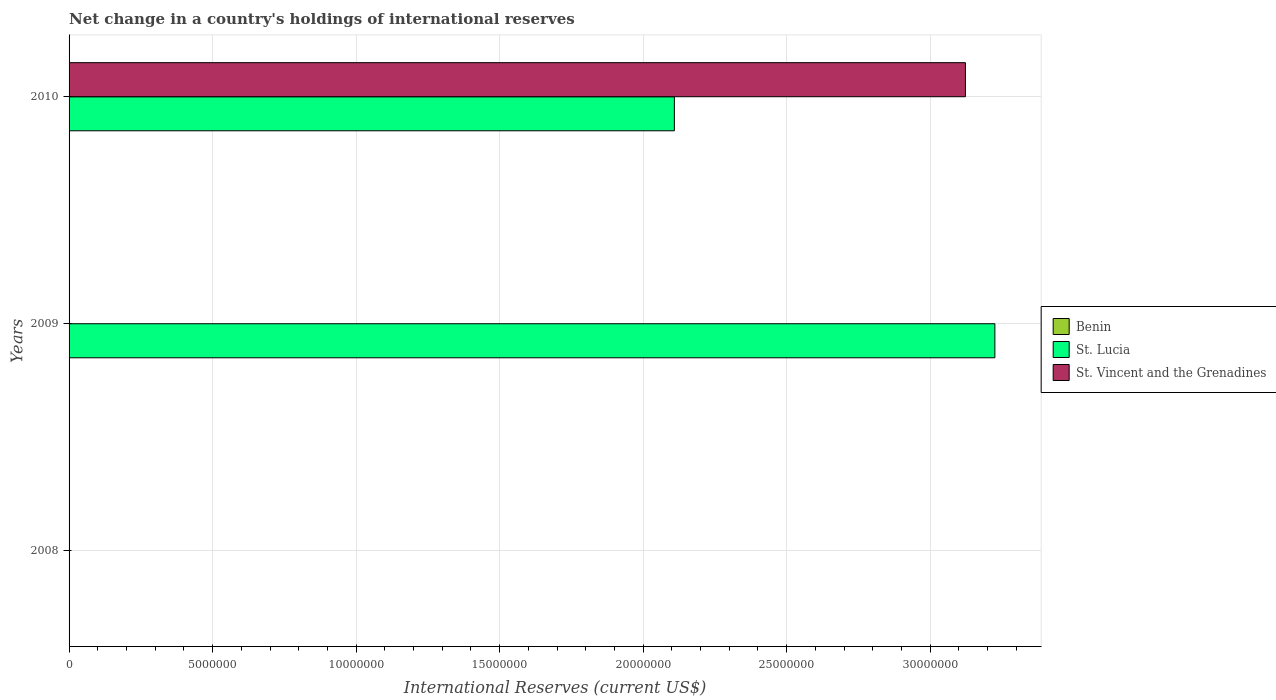Are the number of bars per tick equal to the number of legend labels?
Give a very brief answer. No. Are the number of bars on each tick of the Y-axis equal?
Your answer should be very brief. No. How many bars are there on the 2nd tick from the top?
Give a very brief answer. 1. How many bars are there on the 1st tick from the bottom?
Make the answer very short. 0. What is the label of the 2nd group of bars from the top?
Keep it short and to the point. 2009. In how many cases, is the number of bars for a given year not equal to the number of legend labels?
Your answer should be very brief. 3. Across all years, what is the maximum international reserves in St. Lucia?
Make the answer very short. 3.23e+07. In which year was the international reserves in St. Lucia maximum?
Offer a terse response. 2009. What is the total international reserves in St. Lucia in the graph?
Your answer should be compact. 5.33e+07. What is the difference between the international reserves in St. Vincent and the Grenadines in 2010 and the international reserves in St. Lucia in 2008?
Offer a very short reply. 3.12e+07. In how many years, is the international reserves in St. Vincent and the Grenadines greater than 29000000 US$?
Your response must be concise. 1. Is the international reserves in St. Lucia in 2009 less than that in 2010?
Provide a succinct answer. No. What is the difference between the highest and the lowest international reserves in St. Lucia?
Your response must be concise. 3.23e+07. Is it the case that in every year, the sum of the international reserves in St. Lucia and international reserves in Benin is greater than the international reserves in St. Vincent and the Grenadines?
Offer a very short reply. No. Are all the bars in the graph horizontal?
Make the answer very short. Yes. How many years are there in the graph?
Your answer should be compact. 3. Are the values on the major ticks of X-axis written in scientific E-notation?
Make the answer very short. No. Does the graph contain any zero values?
Provide a short and direct response. Yes. Where does the legend appear in the graph?
Your answer should be very brief. Center right. How many legend labels are there?
Provide a short and direct response. 3. What is the title of the graph?
Your answer should be compact. Net change in a country's holdings of international reserves. Does "Benin" appear as one of the legend labels in the graph?
Keep it short and to the point. Yes. What is the label or title of the X-axis?
Provide a short and direct response. International Reserves (current US$). What is the International Reserves (current US$) in St. Lucia in 2008?
Your answer should be compact. 0. What is the International Reserves (current US$) of St. Vincent and the Grenadines in 2008?
Keep it short and to the point. 0. What is the International Reserves (current US$) of St. Lucia in 2009?
Ensure brevity in your answer.  3.23e+07. What is the International Reserves (current US$) of St. Vincent and the Grenadines in 2009?
Offer a very short reply. 0. What is the International Reserves (current US$) of St. Lucia in 2010?
Your answer should be very brief. 2.11e+07. What is the International Reserves (current US$) of St. Vincent and the Grenadines in 2010?
Offer a terse response. 3.12e+07. Across all years, what is the maximum International Reserves (current US$) in St. Lucia?
Offer a very short reply. 3.23e+07. Across all years, what is the maximum International Reserves (current US$) in St. Vincent and the Grenadines?
Offer a terse response. 3.12e+07. Across all years, what is the minimum International Reserves (current US$) of St. Vincent and the Grenadines?
Keep it short and to the point. 0. What is the total International Reserves (current US$) of St. Lucia in the graph?
Your answer should be very brief. 5.33e+07. What is the total International Reserves (current US$) of St. Vincent and the Grenadines in the graph?
Your answer should be compact. 3.12e+07. What is the difference between the International Reserves (current US$) in St. Lucia in 2009 and that in 2010?
Your answer should be compact. 1.12e+07. What is the difference between the International Reserves (current US$) of St. Lucia in 2009 and the International Reserves (current US$) of St. Vincent and the Grenadines in 2010?
Provide a short and direct response. 1.03e+06. What is the average International Reserves (current US$) in Benin per year?
Your answer should be compact. 0. What is the average International Reserves (current US$) of St. Lucia per year?
Keep it short and to the point. 1.78e+07. What is the average International Reserves (current US$) of St. Vincent and the Grenadines per year?
Your response must be concise. 1.04e+07. In the year 2010, what is the difference between the International Reserves (current US$) of St. Lucia and International Reserves (current US$) of St. Vincent and the Grenadines?
Keep it short and to the point. -1.01e+07. What is the ratio of the International Reserves (current US$) in St. Lucia in 2009 to that in 2010?
Offer a very short reply. 1.53. What is the difference between the highest and the lowest International Reserves (current US$) in St. Lucia?
Keep it short and to the point. 3.23e+07. What is the difference between the highest and the lowest International Reserves (current US$) of St. Vincent and the Grenadines?
Offer a terse response. 3.12e+07. 